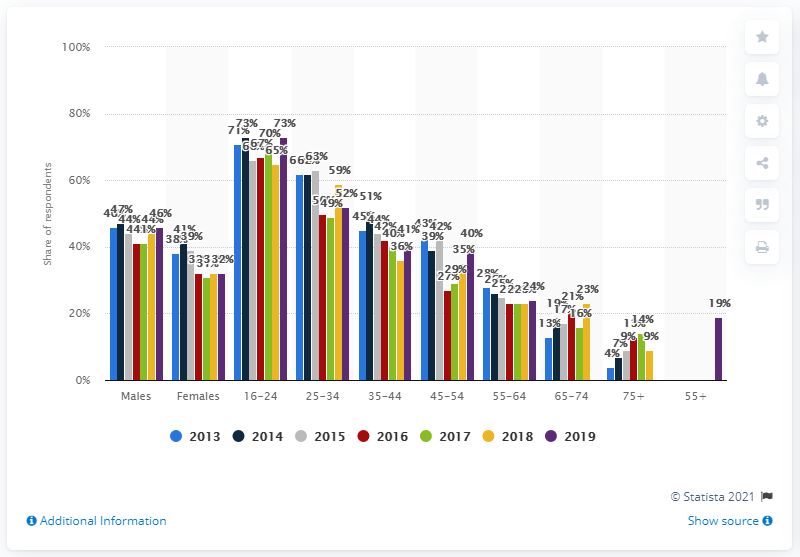Identify some key points in this picture. In 2019, the gaming penetration rate was 39%. 